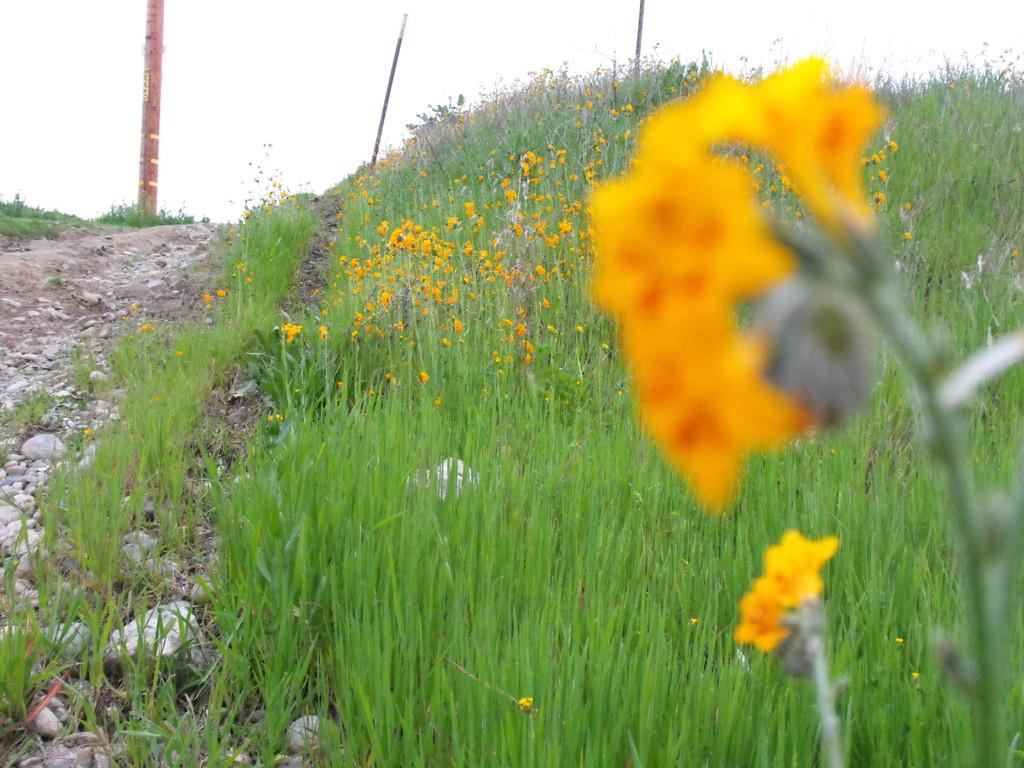What type of vegetation can be seen in the foreground of the image? There is grass and flowering plants in the foreground of the image. What objects can be seen in the background of the image? There is a pole and stones in the background of the image. What is visible in the sky in the background of the image? The sky is visible in the background of the image. When was the image taken? The image was taken during the day. Can you tell me how many cows are grazing in the square in the image? There are no cows or squares present in the image. What advice would the grandmother give to the person in the image? There is no person or grandmother present in the image, so it is not possible to answer this question. 